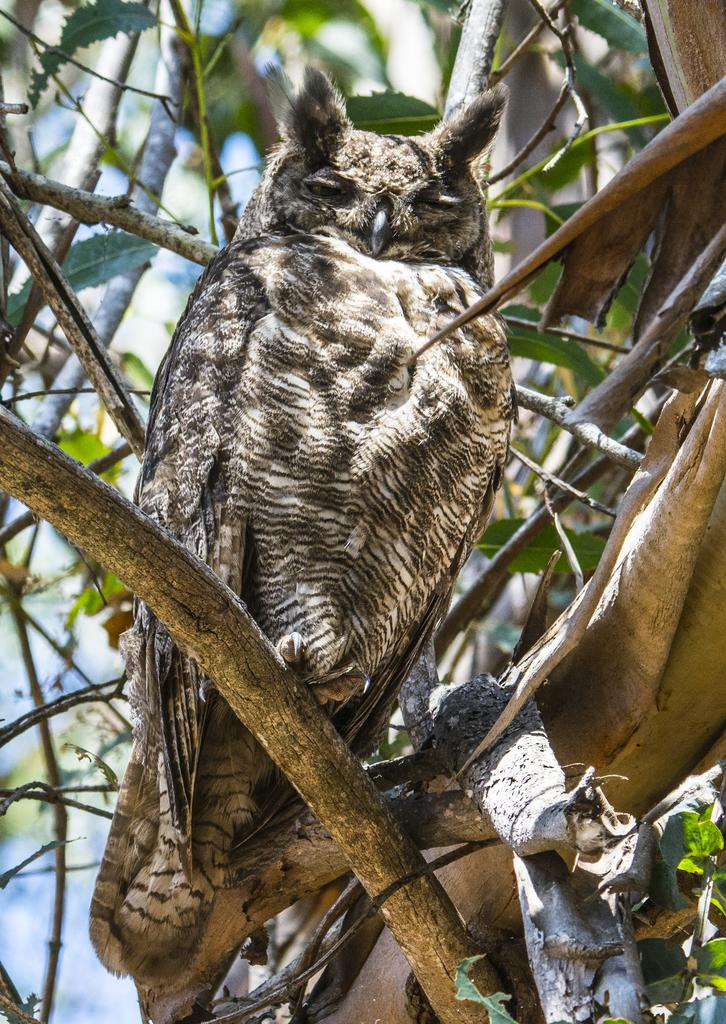What type of animal is in the image? There is an owl in the image. Where is the owl located in the image? The owl is on a branch. In which part of the image is the owl situated? The owl is in the foreground area of the image. How many legs can be seen on the owl in the image? Owls have two legs, but the image only shows the owl's body, so it is not possible to determine the number of legs visible. 